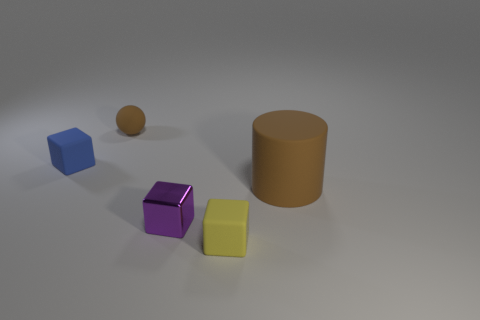Add 1 cylinders. How many objects exist? 6 Subtract all cubes. How many objects are left? 2 Subtract 0 brown blocks. How many objects are left? 5 Subtract all tiny spheres. Subtract all purple metallic blocks. How many objects are left? 3 Add 4 tiny rubber blocks. How many tiny rubber blocks are left? 6 Add 4 brown metal cylinders. How many brown metal cylinders exist? 4 